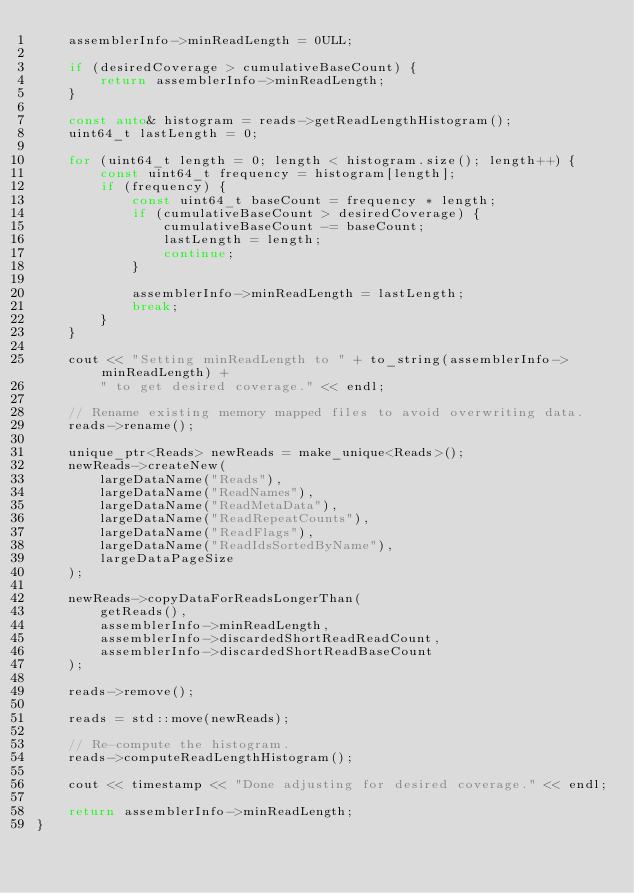<code> <loc_0><loc_0><loc_500><loc_500><_C++_>    assemblerInfo->minReadLength = 0ULL;
        
    if (desiredCoverage > cumulativeBaseCount) {
        return assemblerInfo->minReadLength;
    }

    const auto& histogram = reads->getReadLengthHistogram();
    uint64_t lastLength = 0;

    for (uint64_t length = 0; length < histogram.size(); length++) {
        const uint64_t frequency = histogram[length];
        if (frequency) {
            const uint64_t baseCount = frequency * length;
            if (cumulativeBaseCount > desiredCoverage) {
                cumulativeBaseCount -= baseCount;
                lastLength = length;
                continue;
            }

            assemblerInfo->minReadLength = lastLength;
            break;
        }
    }

    cout << "Setting minReadLength to " + to_string(assemblerInfo->minReadLength) + 
        " to get desired coverage." << endl;

    // Rename existing memory mapped files to avoid overwriting data.
    reads->rename();

    unique_ptr<Reads> newReads = make_unique<Reads>();
    newReads->createNew(
        largeDataName("Reads"),
        largeDataName("ReadNames"),
        largeDataName("ReadMetaData"),
        largeDataName("ReadRepeatCounts"),
        largeDataName("ReadFlags"),
        largeDataName("ReadIdsSortedByName"),
        largeDataPageSize
    );

    newReads->copyDataForReadsLongerThan(
        getReads(),
        assemblerInfo->minReadLength,
        assemblerInfo->discardedShortReadReadCount,
        assemblerInfo->discardedShortReadBaseCount
    );

    reads->remove();
    
    reads = std::move(newReads);

    // Re-compute the histogram.
    reads->computeReadLengthHistogram();

    cout << timestamp << "Done adjusting for desired coverage." << endl;
    
    return assemblerInfo->minReadLength;
}

</code> 